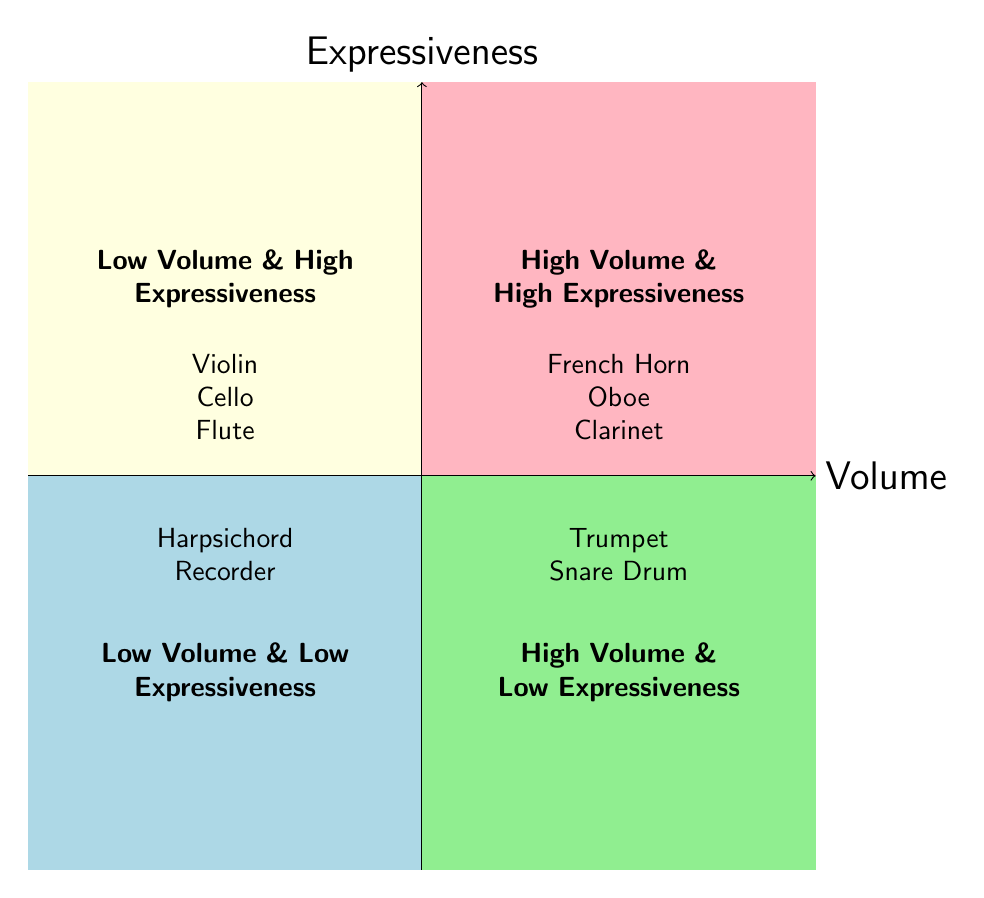What instruments are in the Low Volume & High Expressiveness quadrant? The diagram explicitly lists the instruments in each quadrant. Looking in the Low Volume & High Expressiveness quadrant, the following instruments are present: Violin, Cello, and Flute.
Answer: Violin, Cello, Flute How many instruments are categorized as High Volume & Low Expressiveness? The High Volume & Low Expressiveness quadrant contains two instruments: Trumpet and Snare Drum. Therefore, counting these gives us a total of two instruments.
Answer: 2 Which quadrant contains the Oboe? The Oboe is located in the High Volume & High Expressiveness quadrant. This can be determined by referring to the specific instruments listed in that quadrant.
Answer: High Volume & High Expressiveness Are there any instruments in the Low Volume & Low Expressiveness quadrant that are also in the High Volume & High Expressiveness quadrant? In reviewing both quadrants, the instruments listed in Low Volume & Low Expressiveness are Harpsichord and Recorder, while the High Volume & High Expressiveness quadrant contains French Horn, Oboe, and Clarinet. There are no overlapping instruments.
Answer: No Which quadrant has the highest expressiveness? By analyzing the quadrants, it is clear that both the Low Volume & High Expressiveness and High Volume & High Expressiveness quadrants possess high expressiveness. However, since "highest" is mentioned, we interpret that both quadrants are equally classified under high expressiveness.
Answer: Low Volume & High Expressiveness; High Volume & High Expressiveness How many total quadrants are there in the chart? The diagram contains four quadrants, each designated by a different level of volume and expressiveness. These quadrants are Low Volume & High Expressiveness, High Volume & High Expressiveness, Low Volume & Low Expressiveness, High Volume & Low Expressiveness.
Answer: 4 Which instrument is classified as High Volume but Low Expressiveness? Referring to the diagram, the instruments listed under High Volume & Low Expressiveness are Trumpet and Snare Drum. Since the question asks for one instrument, either can be valid, so we can choose one of them.
Answer: Trumpet Identify one instrument that is Low Volume and High Expressiveness. Among the instruments listed in the Low Volume & High Expressiveness quadrant are Violin, Cello, and Flute. We can state any one of these instruments as an answer.
Answer: Violin 